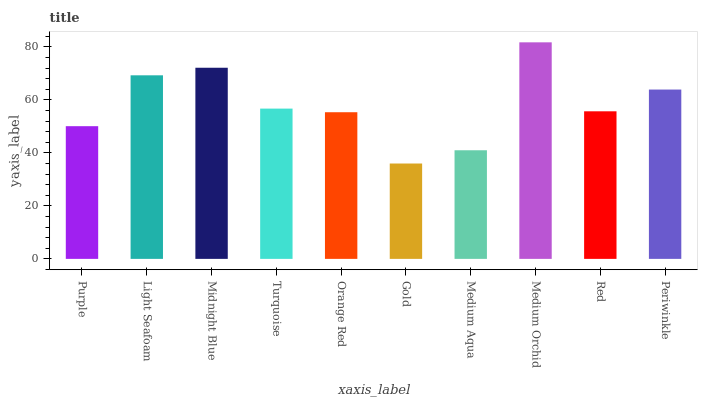Is Light Seafoam the minimum?
Answer yes or no. No. Is Light Seafoam the maximum?
Answer yes or no. No. Is Light Seafoam greater than Purple?
Answer yes or no. Yes. Is Purple less than Light Seafoam?
Answer yes or no. Yes. Is Purple greater than Light Seafoam?
Answer yes or no. No. Is Light Seafoam less than Purple?
Answer yes or no. No. Is Turquoise the high median?
Answer yes or no. Yes. Is Red the low median?
Answer yes or no. Yes. Is Periwinkle the high median?
Answer yes or no. No. Is Purple the low median?
Answer yes or no. No. 